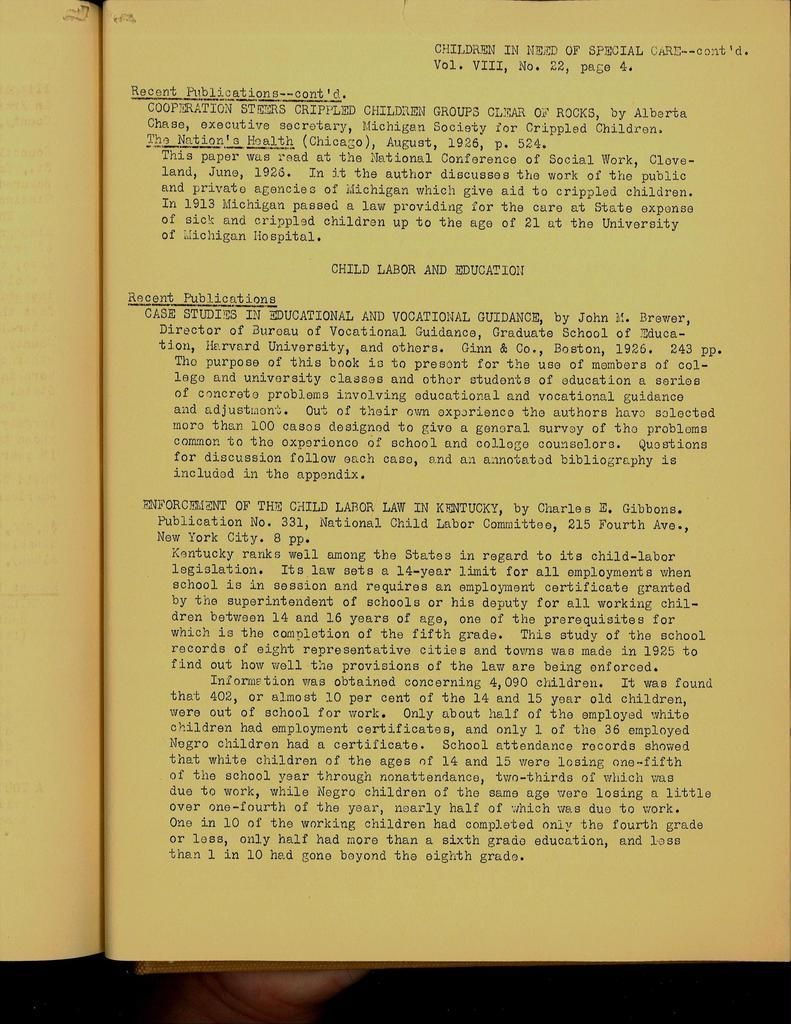<image>
Render a clear and concise summary of the photo. A book with yellowed pages on a page discussing recent publications regarding children in need of special care. 